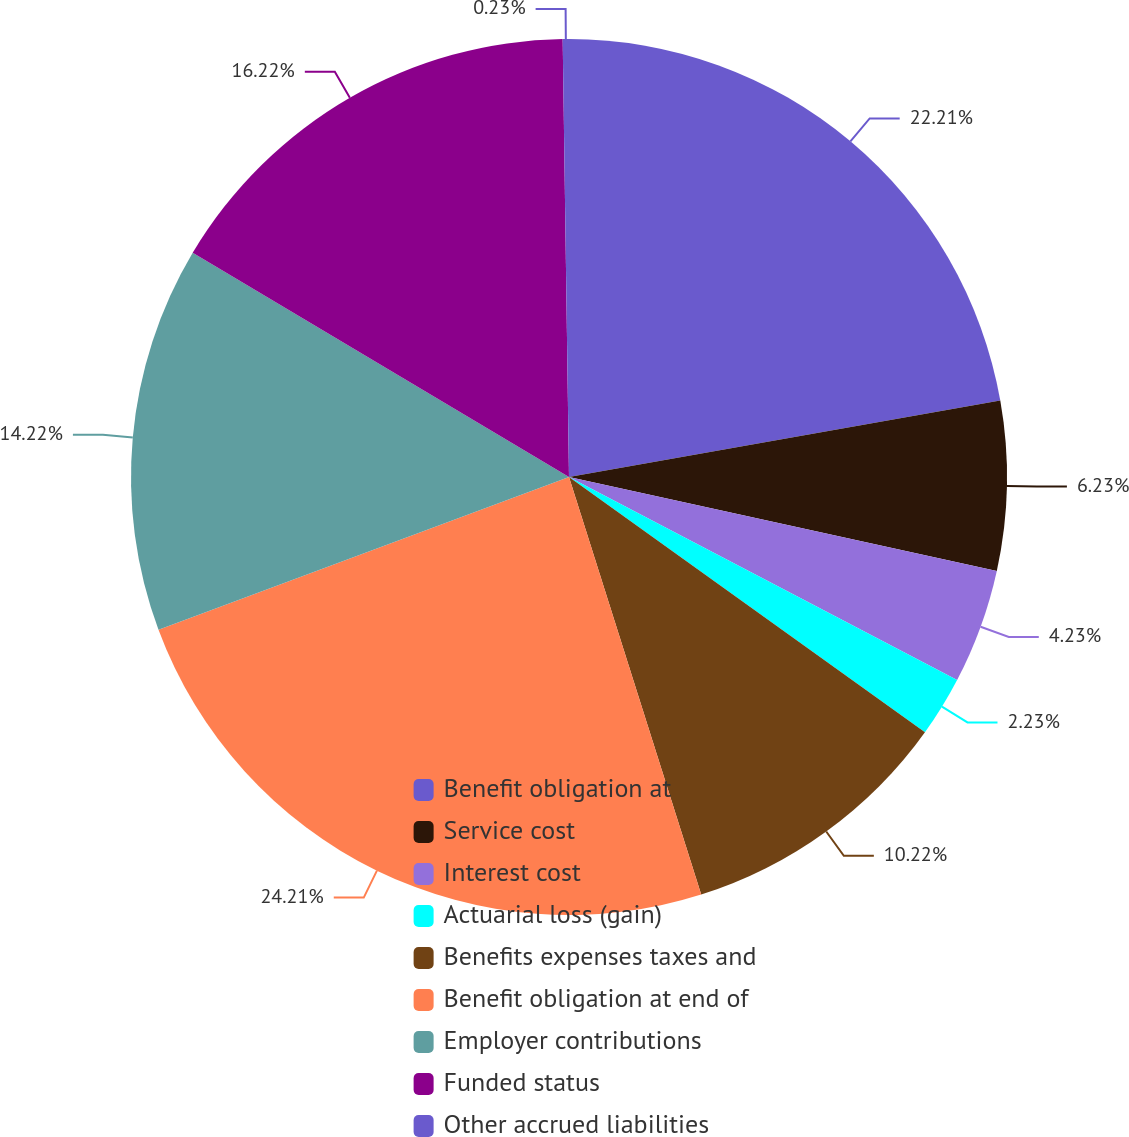Convert chart. <chart><loc_0><loc_0><loc_500><loc_500><pie_chart><fcel>Benefit obligation at<fcel>Service cost<fcel>Interest cost<fcel>Actuarial loss (gain)<fcel>Benefits expenses taxes and<fcel>Benefit obligation at end of<fcel>Employer contributions<fcel>Funded status<fcel>Other accrued liabilities<nl><fcel>22.21%<fcel>6.23%<fcel>4.23%<fcel>2.23%<fcel>10.22%<fcel>24.21%<fcel>14.22%<fcel>16.22%<fcel>0.23%<nl></chart> 